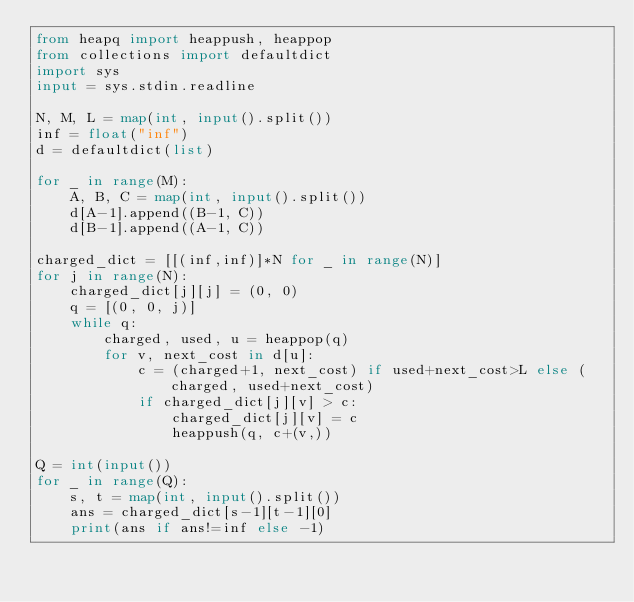Convert code to text. <code><loc_0><loc_0><loc_500><loc_500><_Python_>from heapq import heappush, heappop
from collections import defaultdict
import sys
input = sys.stdin.readline

N, M, L = map(int, input().split())
inf = float("inf")
d = defaultdict(list)

for _ in range(M):
    A, B, C = map(int, input().split())
    d[A-1].append((B-1, C))
    d[B-1].append((A-1, C))

charged_dict = [[(inf,inf)]*N for _ in range(N)]
for j in range(N):
    charged_dict[j][j] = (0, 0)
    q = [(0, 0, j)]
    while q:
        charged, used, u = heappop(q)
        for v, next_cost in d[u]:
            c = (charged+1, next_cost) if used+next_cost>L else (charged, used+next_cost)
            if charged_dict[j][v] > c:
                charged_dict[j][v] = c
                heappush(q, c+(v,))

Q = int(input())
for _ in range(Q):
    s, t = map(int, input().split())
    ans = charged_dict[s-1][t-1][0]
    print(ans if ans!=inf else -1)
</code> 